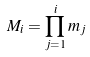Convert formula to latex. <formula><loc_0><loc_0><loc_500><loc_500>M _ { i } = \prod _ { j = 1 } ^ { i } m _ { j }</formula> 